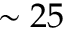Convert formula to latex. <formula><loc_0><loc_0><loc_500><loc_500>\sim 2 5</formula> 